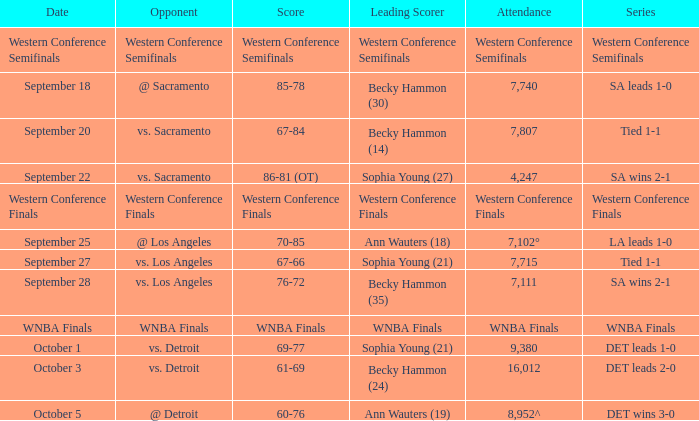Who is the leading scorer of the wnba finals series? WNBA Finals. 